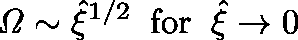Convert formula to latex. <formula><loc_0><loc_0><loc_500><loc_500>\Omega \sim \hat { \xi } ^ { 1 / 2 } \, f o r \, \hat { \xi } \rightarrow 0</formula> 